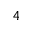<formula> <loc_0><loc_0><loc_500><loc_500>4</formula> 